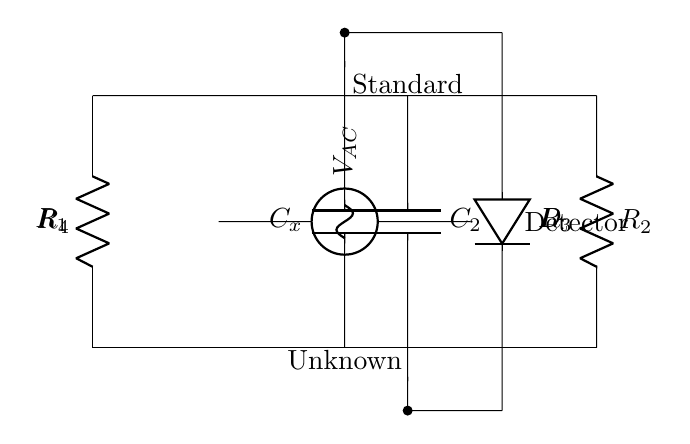What is the role of component C_x? Component C_x is the unknown capacitor being tested in the circuit, indicated by the label. It is the capacitance that we are measuring.
Answer: Unknown capacitor How many resistors are in this circuit? The circuit has four resistors: R_1, R_2, R_3, and R_4. Each is clearly labeled in the diagram.
Answer: Four What is the voltage source type in this circuit? The voltage source is labeled as V_AC, indicating it is an alternating current voltage source. This is essential for the operation of the AC bridge to compare capacitances.
Answer: AC What is the purpose of the detector in this circuit? The detector is used to measure the output or difference in signals between the bridge's arms A and B, helping to determine the balance of the bridge, which correlates with the capacitance measurement.
Answer: Measure What is the function of the capacitors C_1 and C_2 in this circuit? Capacitor C_1 (C_x) is the unknown capacitor to be measured, while C_2 is a standard capacitor. These capacitors are part of a bridge circuit that helps measure the unknown capacitance by balancing the bridge.
Answer: Measure capacitance What is the expected condition for the bridge to be balanced? The bridge is balanced when the voltage across the detector is zero, indicating that the ratios of the capacitances and resistances in the circuit are equal.
Answer: Zero voltage Which component indicates the standard capacitor in this circuit? The standard capacitor is labeled C_2, which is the known reference capacitor used for comparison in the measurement of the unknown capacitance C_x.
Answer: C_2 